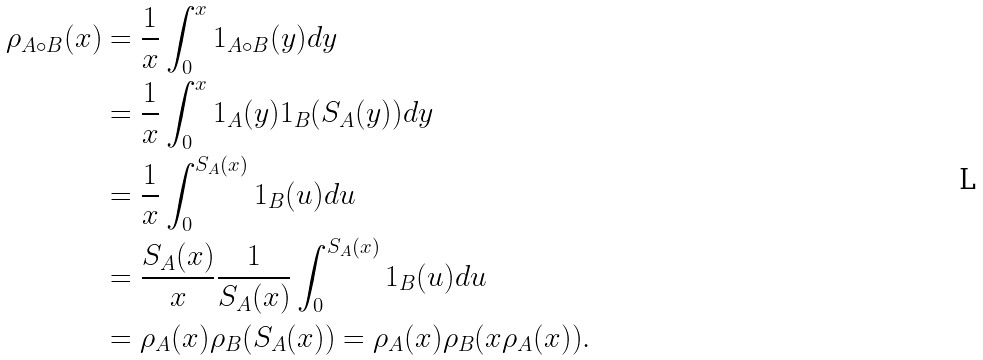<formula> <loc_0><loc_0><loc_500><loc_500>\rho _ { A \circ B } ( x ) & = \frac { 1 } { x } \int _ { 0 } ^ { x } 1 _ { A \circ B } ( y ) d y \\ & = \frac { 1 } { x } \int _ { 0 } ^ { x } 1 _ { A } ( y ) 1 _ { B } ( S _ { A } ( y ) ) d y \\ & = \frac { 1 } { x } \int _ { 0 } ^ { S _ { A } ( x ) } 1 _ { B } ( u ) d u \\ & = \frac { S _ { A } ( x ) } { x } \frac { 1 } { S _ { A } ( x ) } \int _ { 0 } ^ { S _ { A } ( x ) } 1 _ { B } ( u ) d u \\ & = \rho _ { A } ( x ) \rho _ { B } ( S _ { A } ( x ) ) = \rho _ { A } ( x ) \rho _ { B } ( x \rho _ { A } ( x ) ) .</formula> 